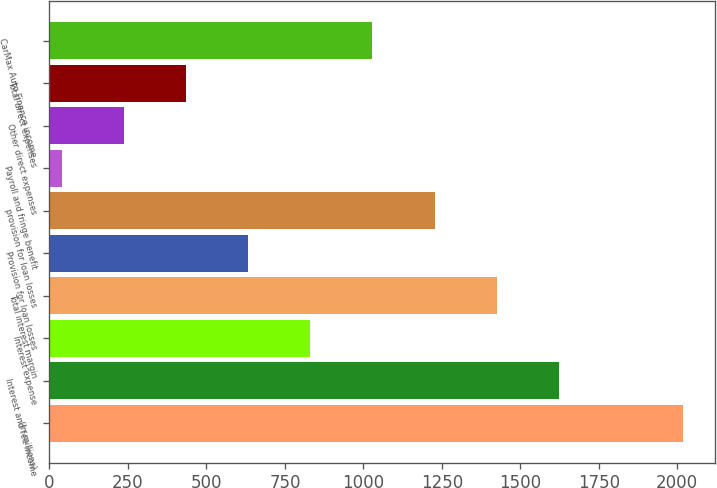<chart> <loc_0><loc_0><loc_500><loc_500><bar_chart><fcel>(In millions)<fcel>Interest and fee income<fcel>Interest expense<fcel>Total interest margin<fcel>Provision for loan losses<fcel>provision for loan losses<fcel>Payroll and fringe benefit<fcel>Other direct expenses<fcel>Total direct expenses<fcel>CarMax Auto Finance income<nl><fcel>2019<fcel>1622.86<fcel>830.58<fcel>1424.79<fcel>632.51<fcel>1226.72<fcel>38.3<fcel>236.37<fcel>434.44<fcel>1028.65<nl></chart> 